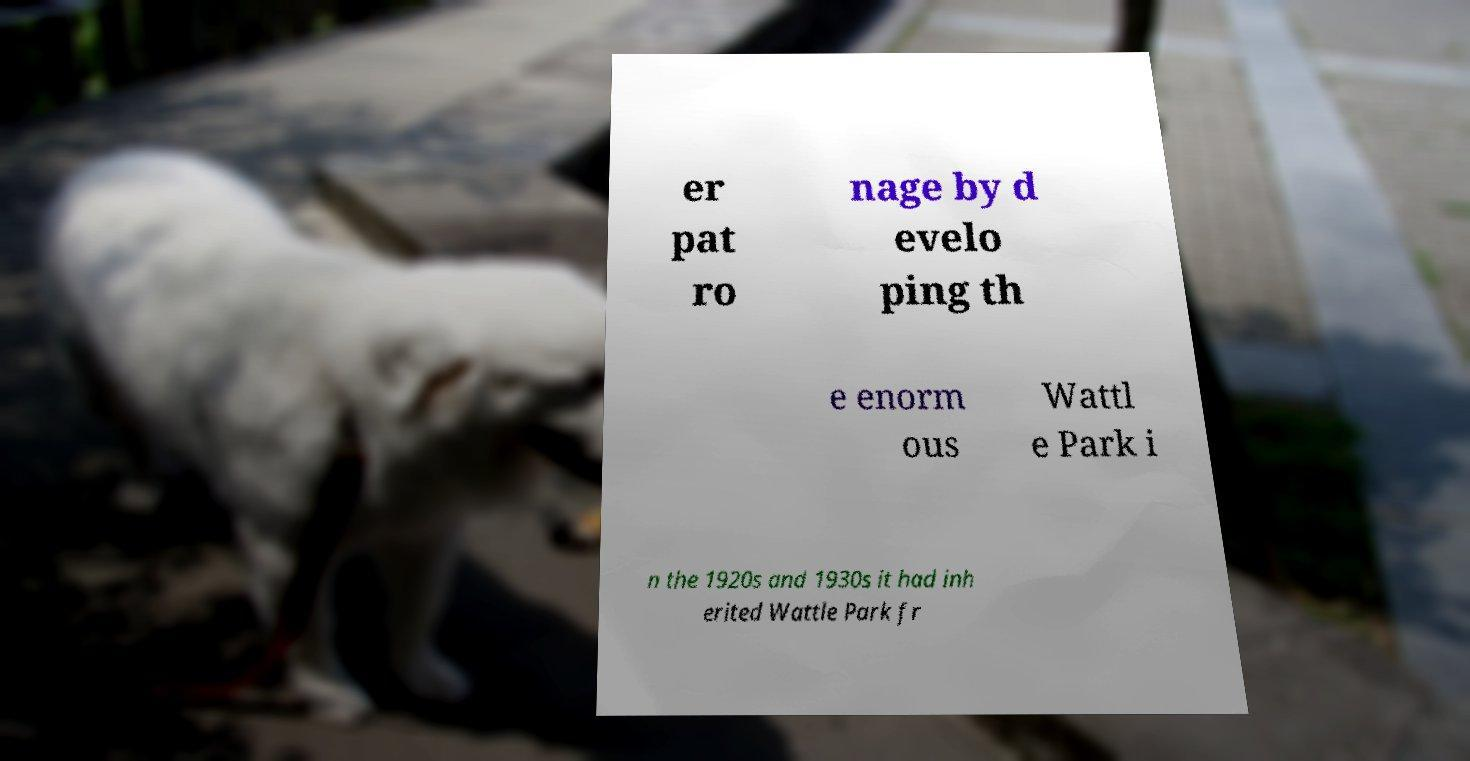Can you accurately transcribe the text from the provided image for me? er pat ro nage by d evelo ping th e enorm ous Wattl e Park i n the 1920s and 1930s it had inh erited Wattle Park fr 